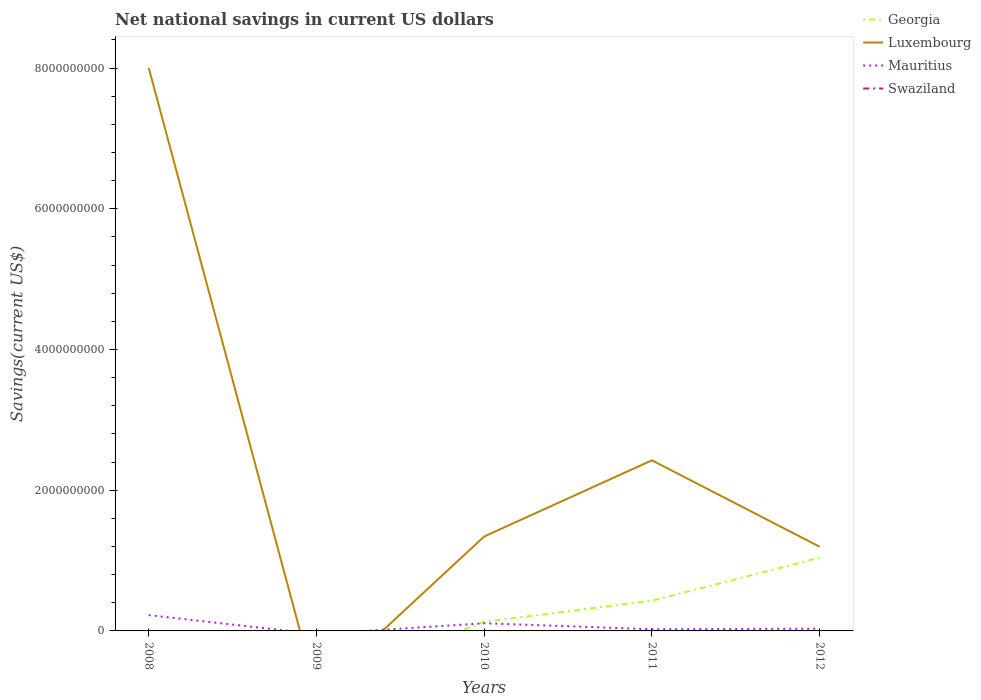How many different coloured lines are there?
Offer a very short reply. 3. What is the total net national savings in Mauritius in the graph?
Your answer should be very brief. -8.32e+06. What is the difference between the highest and the second highest net national savings in Luxembourg?
Make the answer very short. 8.00e+09. What is the difference between two consecutive major ticks on the Y-axis?
Offer a very short reply. 2.00e+09. Are the values on the major ticks of Y-axis written in scientific E-notation?
Give a very brief answer. No. Where does the legend appear in the graph?
Provide a short and direct response. Top right. How are the legend labels stacked?
Ensure brevity in your answer.  Vertical. What is the title of the graph?
Give a very brief answer. Net national savings in current US dollars. What is the label or title of the X-axis?
Ensure brevity in your answer.  Years. What is the label or title of the Y-axis?
Give a very brief answer. Savings(current US$). What is the Savings(current US$) in Georgia in 2008?
Your answer should be compact. 0. What is the Savings(current US$) in Luxembourg in 2008?
Offer a very short reply. 8.00e+09. What is the Savings(current US$) in Mauritius in 2008?
Keep it short and to the point. 2.24e+08. What is the Savings(current US$) of Georgia in 2009?
Give a very brief answer. 0. What is the Savings(current US$) of Mauritius in 2009?
Keep it short and to the point. 0. What is the Savings(current US$) of Swaziland in 2009?
Offer a very short reply. 0. What is the Savings(current US$) of Georgia in 2010?
Ensure brevity in your answer.  1.30e+08. What is the Savings(current US$) of Luxembourg in 2010?
Ensure brevity in your answer.  1.34e+09. What is the Savings(current US$) in Mauritius in 2010?
Provide a short and direct response. 1.09e+08. What is the Savings(current US$) in Georgia in 2011?
Provide a succinct answer. 4.29e+08. What is the Savings(current US$) of Luxembourg in 2011?
Offer a terse response. 2.42e+09. What is the Savings(current US$) in Mauritius in 2011?
Ensure brevity in your answer.  2.38e+07. What is the Savings(current US$) of Georgia in 2012?
Offer a very short reply. 1.04e+09. What is the Savings(current US$) in Luxembourg in 2012?
Your response must be concise. 1.20e+09. What is the Savings(current US$) of Mauritius in 2012?
Ensure brevity in your answer.  3.21e+07. What is the Savings(current US$) in Swaziland in 2012?
Provide a succinct answer. 0. Across all years, what is the maximum Savings(current US$) in Georgia?
Provide a short and direct response. 1.04e+09. Across all years, what is the maximum Savings(current US$) in Luxembourg?
Give a very brief answer. 8.00e+09. Across all years, what is the maximum Savings(current US$) in Mauritius?
Keep it short and to the point. 2.24e+08. Across all years, what is the minimum Savings(current US$) in Georgia?
Your answer should be compact. 0. Across all years, what is the minimum Savings(current US$) of Luxembourg?
Give a very brief answer. 0. What is the total Savings(current US$) of Georgia in the graph?
Your response must be concise. 1.60e+09. What is the total Savings(current US$) of Luxembourg in the graph?
Offer a very short reply. 1.30e+1. What is the total Savings(current US$) in Mauritius in the graph?
Your answer should be very brief. 3.90e+08. What is the difference between the Savings(current US$) in Luxembourg in 2008 and that in 2010?
Keep it short and to the point. 6.66e+09. What is the difference between the Savings(current US$) of Mauritius in 2008 and that in 2010?
Make the answer very short. 1.15e+08. What is the difference between the Savings(current US$) in Luxembourg in 2008 and that in 2011?
Make the answer very short. 5.58e+09. What is the difference between the Savings(current US$) in Mauritius in 2008 and that in 2011?
Offer a terse response. 2.01e+08. What is the difference between the Savings(current US$) in Luxembourg in 2008 and that in 2012?
Your answer should be compact. 6.81e+09. What is the difference between the Savings(current US$) of Mauritius in 2008 and that in 2012?
Your answer should be very brief. 1.92e+08. What is the difference between the Savings(current US$) in Georgia in 2010 and that in 2011?
Ensure brevity in your answer.  -3.00e+08. What is the difference between the Savings(current US$) of Luxembourg in 2010 and that in 2011?
Make the answer very short. -1.08e+09. What is the difference between the Savings(current US$) in Mauritius in 2010 and that in 2011?
Provide a succinct answer. 8.54e+07. What is the difference between the Savings(current US$) of Georgia in 2010 and that in 2012?
Provide a succinct answer. -9.12e+08. What is the difference between the Savings(current US$) in Luxembourg in 2010 and that in 2012?
Make the answer very short. 1.46e+08. What is the difference between the Savings(current US$) of Mauritius in 2010 and that in 2012?
Offer a terse response. 7.71e+07. What is the difference between the Savings(current US$) in Georgia in 2011 and that in 2012?
Give a very brief answer. -6.12e+08. What is the difference between the Savings(current US$) in Luxembourg in 2011 and that in 2012?
Give a very brief answer. 1.23e+09. What is the difference between the Savings(current US$) of Mauritius in 2011 and that in 2012?
Offer a terse response. -8.32e+06. What is the difference between the Savings(current US$) of Luxembourg in 2008 and the Savings(current US$) of Mauritius in 2010?
Offer a terse response. 7.89e+09. What is the difference between the Savings(current US$) in Luxembourg in 2008 and the Savings(current US$) in Mauritius in 2011?
Offer a terse response. 7.98e+09. What is the difference between the Savings(current US$) of Luxembourg in 2008 and the Savings(current US$) of Mauritius in 2012?
Your response must be concise. 7.97e+09. What is the difference between the Savings(current US$) in Georgia in 2010 and the Savings(current US$) in Luxembourg in 2011?
Keep it short and to the point. -2.30e+09. What is the difference between the Savings(current US$) in Georgia in 2010 and the Savings(current US$) in Mauritius in 2011?
Offer a very short reply. 1.06e+08. What is the difference between the Savings(current US$) in Luxembourg in 2010 and the Savings(current US$) in Mauritius in 2011?
Provide a short and direct response. 1.32e+09. What is the difference between the Savings(current US$) of Georgia in 2010 and the Savings(current US$) of Luxembourg in 2012?
Your answer should be very brief. -1.07e+09. What is the difference between the Savings(current US$) of Georgia in 2010 and the Savings(current US$) of Mauritius in 2012?
Your answer should be very brief. 9.75e+07. What is the difference between the Savings(current US$) of Luxembourg in 2010 and the Savings(current US$) of Mauritius in 2012?
Ensure brevity in your answer.  1.31e+09. What is the difference between the Savings(current US$) in Georgia in 2011 and the Savings(current US$) in Luxembourg in 2012?
Your response must be concise. -7.67e+08. What is the difference between the Savings(current US$) in Georgia in 2011 and the Savings(current US$) in Mauritius in 2012?
Keep it short and to the point. 3.97e+08. What is the difference between the Savings(current US$) of Luxembourg in 2011 and the Savings(current US$) of Mauritius in 2012?
Offer a terse response. 2.39e+09. What is the average Savings(current US$) of Georgia per year?
Provide a short and direct response. 3.20e+08. What is the average Savings(current US$) of Luxembourg per year?
Give a very brief answer. 2.59e+09. What is the average Savings(current US$) of Mauritius per year?
Keep it short and to the point. 7.79e+07. What is the average Savings(current US$) in Swaziland per year?
Offer a very short reply. 0. In the year 2008, what is the difference between the Savings(current US$) in Luxembourg and Savings(current US$) in Mauritius?
Provide a short and direct response. 7.78e+09. In the year 2010, what is the difference between the Savings(current US$) in Georgia and Savings(current US$) in Luxembourg?
Make the answer very short. -1.21e+09. In the year 2010, what is the difference between the Savings(current US$) in Georgia and Savings(current US$) in Mauritius?
Make the answer very short. 2.04e+07. In the year 2010, what is the difference between the Savings(current US$) of Luxembourg and Savings(current US$) of Mauritius?
Your response must be concise. 1.23e+09. In the year 2011, what is the difference between the Savings(current US$) of Georgia and Savings(current US$) of Luxembourg?
Offer a very short reply. -2.00e+09. In the year 2011, what is the difference between the Savings(current US$) in Georgia and Savings(current US$) in Mauritius?
Your answer should be very brief. 4.06e+08. In the year 2011, what is the difference between the Savings(current US$) of Luxembourg and Savings(current US$) of Mauritius?
Make the answer very short. 2.40e+09. In the year 2012, what is the difference between the Savings(current US$) in Georgia and Savings(current US$) in Luxembourg?
Keep it short and to the point. -1.55e+08. In the year 2012, what is the difference between the Savings(current US$) of Georgia and Savings(current US$) of Mauritius?
Provide a short and direct response. 1.01e+09. In the year 2012, what is the difference between the Savings(current US$) of Luxembourg and Savings(current US$) of Mauritius?
Keep it short and to the point. 1.16e+09. What is the ratio of the Savings(current US$) of Luxembourg in 2008 to that in 2010?
Offer a very short reply. 5.96. What is the ratio of the Savings(current US$) in Mauritius in 2008 to that in 2010?
Offer a very short reply. 2.06. What is the ratio of the Savings(current US$) in Luxembourg in 2008 to that in 2011?
Your answer should be very brief. 3.3. What is the ratio of the Savings(current US$) in Mauritius in 2008 to that in 2011?
Give a very brief answer. 9.43. What is the ratio of the Savings(current US$) in Luxembourg in 2008 to that in 2012?
Provide a short and direct response. 6.69. What is the ratio of the Savings(current US$) of Mauritius in 2008 to that in 2012?
Offer a very short reply. 6.99. What is the ratio of the Savings(current US$) of Georgia in 2010 to that in 2011?
Your response must be concise. 0.3. What is the ratio of the Savings(current US$) in Luxembourg in 2010 to that in 2011?
Offer a very short reply. 0.55. What is the ratio of the Savings(current US$) in Mauritius in 2010 to that in 2011?
Keep it short and to the point. 4.59. What is the ratio of the Savings(current US$) of Georgia in 2010 to that in 2012?
Ensure brevity in your answer.  0.12. What is the ratio of the Savings(current US$) in Luxembourg in 2010 to that in 2012?
Make the answer very short. 1.12. What is the ratio of the Savings(current US$) of Mauritius in 2010 to that in 2012?
Keep it short and to the point. 3.4. What is the ratio of the Savings(current US$) of Georgia in 2011 to that in 2012?
Provide a short and direct response. 0.41. What is the ratio of the Savings(current US$) in Luxembourg in 2011 to that in 2012?
Offer a terse response. 2.03. What is the ratio of the Savings(current US$) in Mauritius in 2011 to that in 2012?
Offer a terse response. 0.74. What is the difference between the highest and the second highest Savings(current US$) of Georgia?
Make the answer very short. 6.12e+08. What is the difference between the highest and the second highest Savings(current US$) in Luxembourg?
Offer a terse response. 5.58e+09. What is the difference between the highest and the second highest Savings(current US$) in Mauritius?
Offer a very short reply. 1.15e+08. What is the difference between the highest and the lowest Savings(current US$) of Georgia?
Your answer should be compact. 1.04e+09. What is the difference between the highest and the lowest Savings(current US$) in Luxembourg?
Your answer should be very brief. 8.00e+09. What is the difference between the highest and the lowest Savings(current US$) of Mauritius?
Your answer should be compact. 2.24e+08. 